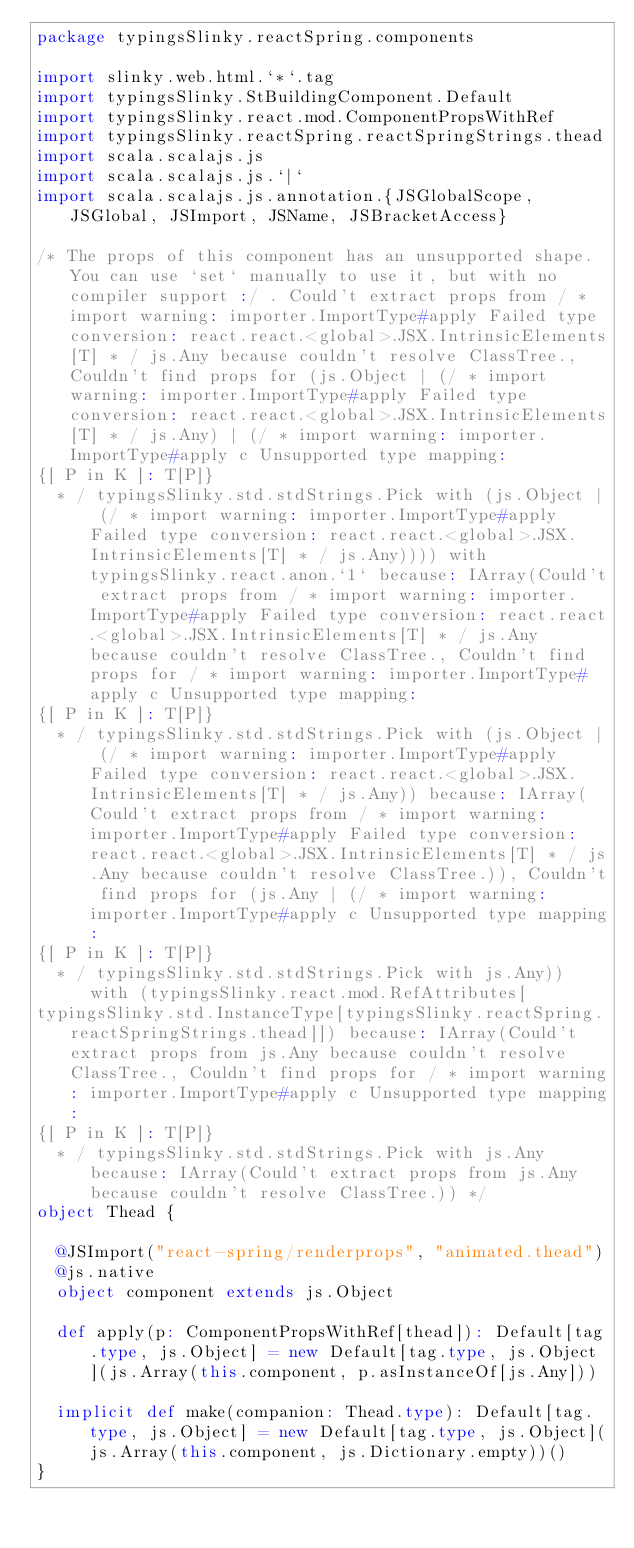<code> <loc_0><loc_0><loc_500><loc_500><_Scala_>package typingsSlinky.reactSpring.components

import slinky.web.html.`*`.tag
import typingsSlinky.StBuildingComponent.Default
import typingsSlinky.react.mod.ComponentPropsWithRef
import typingsSlinky.reactSpring.reactSpringStrings.thead
import scala.scalajs.js
import scala.scalajs.js.`|`
import scala.scalajs.js.annotation.{JSGlobalScope, JSGlobal, JSImport, JSName, JSBracketAccess}

/* The props of this component has an unsupported shape. You can use `set` manually to use it, but with no compiler support :/ . Could't extract props from / * import warning: importer.ImportType#apply Failed type conversion: react.react.<global>.JSX.IntrinsicElements[T] * / js.Any because couldn't resolve ClassTree., Couldn't find props for (js.Object | (/ * import warning: importer.ImportType#apply Failed type conversion: react.react.<global>.JSX.IntrinsicElements[T] * / js.Any) | (/ * import warning: importer.ImportType#apply c Unsupported type mapping: 
{[ P in K ]: T[P]}
  * / typingsSlinky.std.stdStrings.Pick with (js.Object | (/ * import warning: importer.ImportType#apply Failed type conversion: react.react.<global>.JSX.IntrinsicElements[T] * / js.Any)))) with typingsSlinky.react.anon.`1` because: IArray(Could't extract props from / * import warning: importer.ImportType#apply Failed type conversion: react.react.<global>.JSX.IntrinsicElements[T] * / js.Any because couldn't resolve ClassTree., Couldn't find props for / * import warning: importer.ImportType#apply c Unsupported type mapping: 
{[ P in K ]: T[P]}
  * / typingsSlinky.std.stdStrings.Pick with (js.Object | (/ * import warning: importer.ImportType#apply Failed type conversion: react.react.<global>.JSX.IntrinsicElements[T] * / js.Any)) because: IArray(Could't extract props from / * import warning: importer.ImportType#apply Failed type conversion: react.react.<global>.JSX.IntrinsicElements[T] * / js.Any because couldn't resolve ClassTree.)), Couldn't find props for (js.Any | (/ * import warning: importer.ImportType#apply c Unsupported type mapping: 
{[ P in K ]: T[P]}
  * / typingsSlinky.std.stdStrings.Pick with js.Any)) with (typingsSlinky.react.mod.RefAttributes[
typingsSlinky.std.InstanceType[typingsSlinky.reactSpring.reactSpringStrings.thead]]) because: IArray(Could't extract props from js.Any because couldn't resolve ClassTree., Couldn't find props for / * import warning: importer.ImportType#apply c Unsupported type mapping: 
{[ P in K ]: T[P]}
  * / typingsSlinky.std.stdStrings.Pick with js.Any because: IArray(Could't extract props from js.Any because couldn't resolve ClassTree.)) */
object Thead {
  
  @JSImport("react-spring/renderprops", "animated.thead")
  @js.native
  object component extends js.Object
  
  def apply(p: ComponentPropsWithRef[thead]): Default[tag.type, js.Object] = new Default[tag.type, js.Object](js.Array(this.component, p.asInstanceOf[js.Any]))
  
  implicit def make(companion: Thead.type): Default[tag.type, js.Object] = new Default[tag.type, js.Object](js.Array(this.component, js.Dictionary.empty))()
}
</code> 